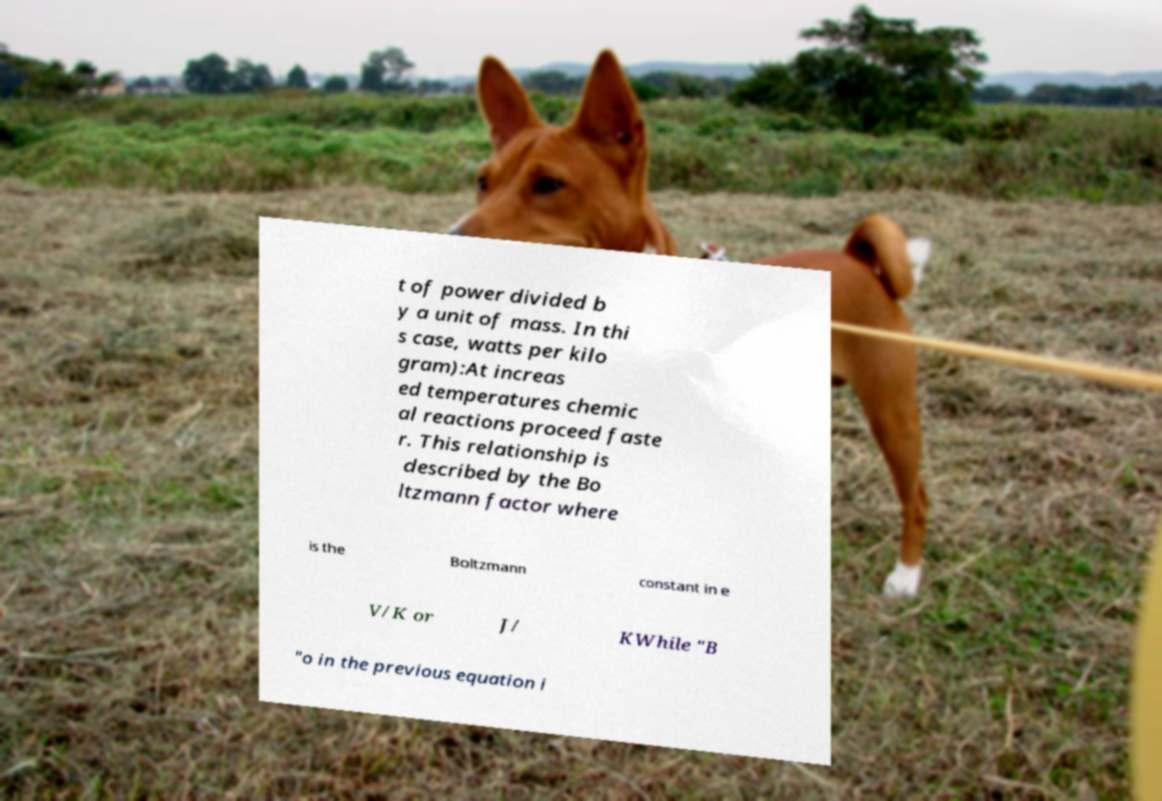Can you accurately transcribe the text from the provided image for me? t of power divided b y a unit of mass. In thi s case, watts per kilo gram):At increas ed temperatures chemic al reactions proceed faste r. This relationship is described by the Bo ltzmann factor where is the Boltzmann constant in e V/K or J/ KWhile "B "o in the previous equation i 